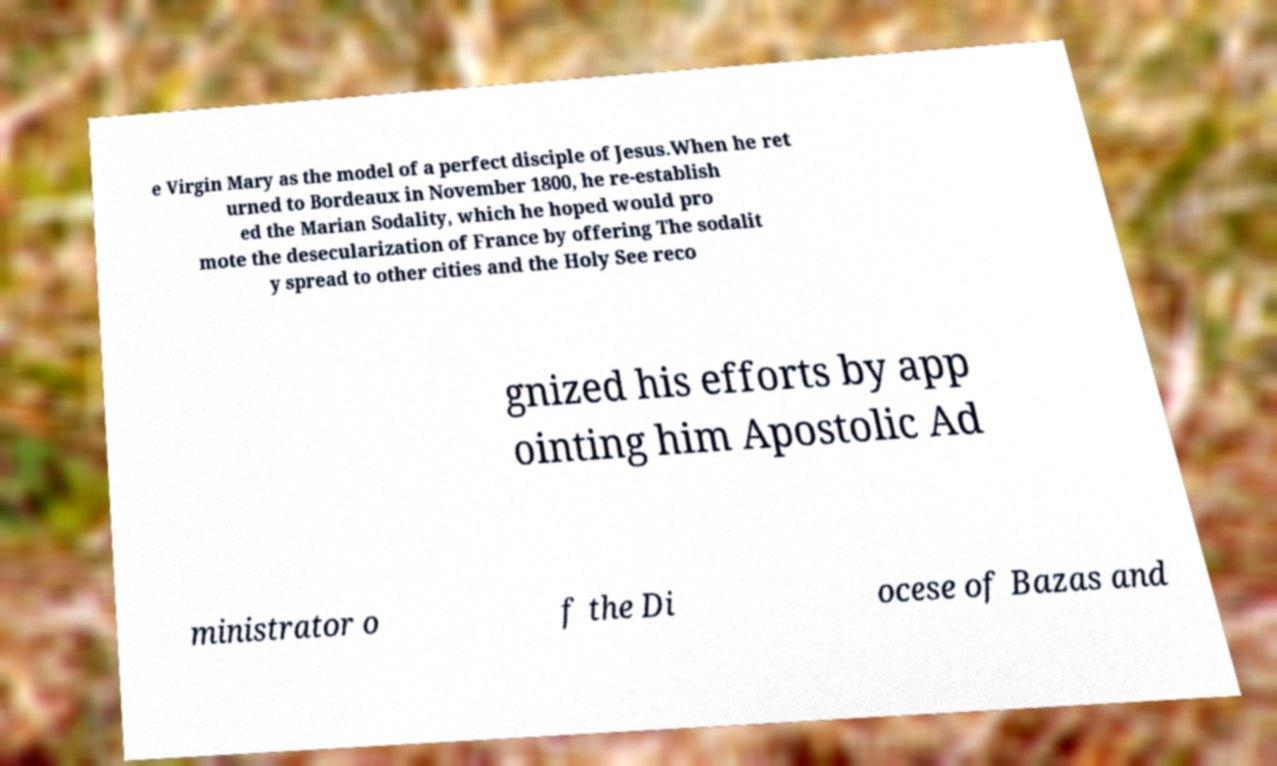Can you accurately transcribe the text from the provided image for me? e Virgin Mary as the model of a perfect disciple of Jesus.When he ret urned to Bordeaux in November 1800, he re-establish ed the Marian Sodality, which he hoped would pro mote the desecularization of France by offering The sodalit y spread to other cities and the Holy See reco gnized his efforts by app ointing him Apostolic Ad ministrator o f the Di ocese of Bazas and 